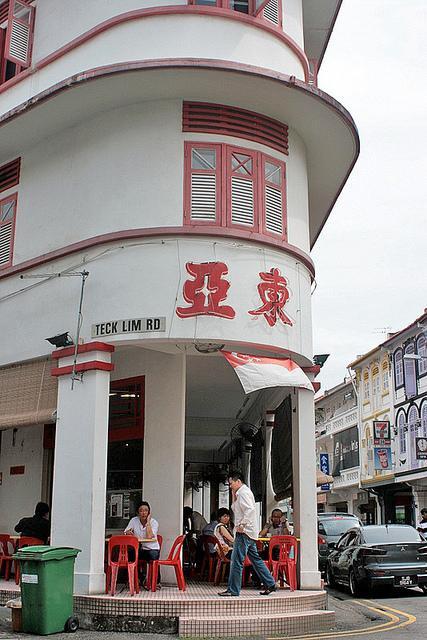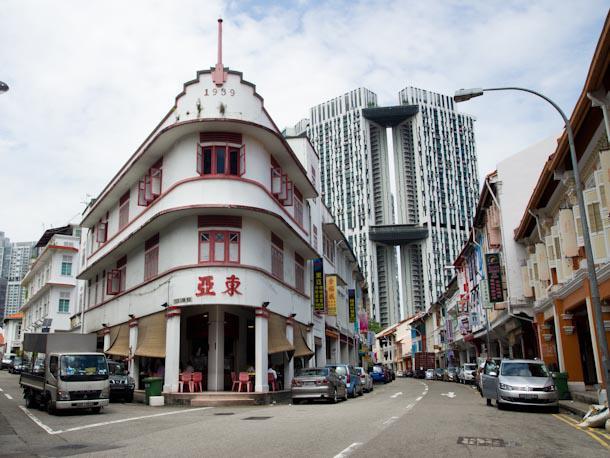The first image is the image on the left, the second image is the image on the right. Evaluate the accuracy of this statement regarding the images: "Left and right images show the same red-trimmed white building which curves around the corner with a row of columns.". Is it true? Answer yes or no. Yes. The first image is the image on the left, the second image is the image on the right. Evaluate the accuracy of this statement regarding the images: "There is a yellow sign above the door with asian lettering". Is it true? Answer yes or no. No. 